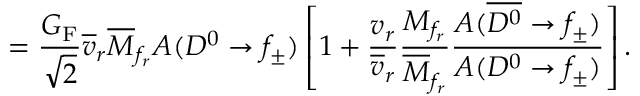<formula> <loc_0><loc_0><loc_500><loc_500>= \frac { G _ { F } } { \sqrt { 2 } } \overline { v } _ { r } \overline { M } _ { f _ { r } } A ( D ^ { 0 } \to f _ { \pm } ) \left [ 1 + \frac { v _ { r } } { \overline { v } _ { r } } \frac { M _ { f _ { r } } } { \overline { M } _ { f _ { r } } } \frac { A ( \overline { { { D ^ { 0 } } } } \to f _ { \pm } ) } { A ( D ^ { 0 } \to f _ { \pm } ) } \right ] .</formula> 